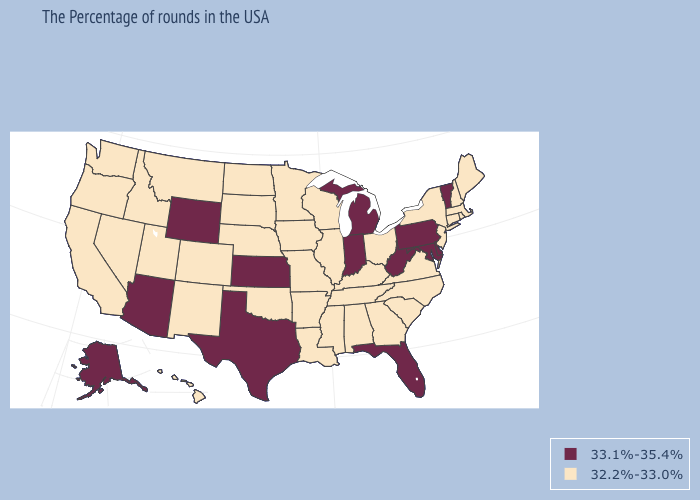Does the first symbol in the legend represent the smallest category?
Keep it brief. No. What is the value of Michigan?
Short answer required. 33.1%-35.4%. Name the states that have a value in the range 33.1%-35.4%?
Give a very brief answer. Vermont, Delaware, Maryland, Pennsylvania, West Virginia, Florida, Michigan, Indiana, Kansas, Texas, Wyoming, Arizona, Alaska. Does the map have missing data?
Quick response, please. No. Does Kansas have the same value as Delaware?
Keep it brief. Yes. Does Michigan have a lower value than Maine?
Answer briefly. No. Name the states that have a value in the range 33.1%-35.4%?
Write a very short answer. Vermont, Delaware, Maryland, Pennsylvania, West Virginia, Florida, Michigan, Indiana, Kansas, Texas, Wyoming, Arizona, Alaska. Does Florida have the same value as North Carolina?
Keep it brief. No. Name the states that have a value in the range 33.1%-35.4%?
Quick response, please. Vermont, Delaware, Maryland, Pennsylvania, West Virginia, Florida, Michigan, Indiana, Kansas, Texas, Wyoming, Arizona, Alaska. Does Texas have the lowest value in the South?
Quick response, please. No. What is the value of Oregon?
Short answer required. 32.2%-33.0%. How many symbols are there in the legend?
Answer briefly. 2. What is the value of Tennessee?
Concise answer only. 32.2%-33.0%. Name the states that have a value in the range 33.1%-35.4%?
Keep it brief. Vermont, Delaware, Maryland, Pennsylvania, West Virginia, Florida, Michigan, Indiana, Kansas, Texas, Wyoming, Arizona, Alaska. What is the highest value in states that border Virginia?
Write a very short answer. 33.1%-35.4%. 